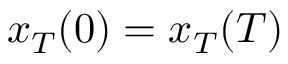<formula> <loc_0><loc_0><loc_500><loc_500>x _ { T } ( 0 ) = x _ { T } ( T )</formula> 